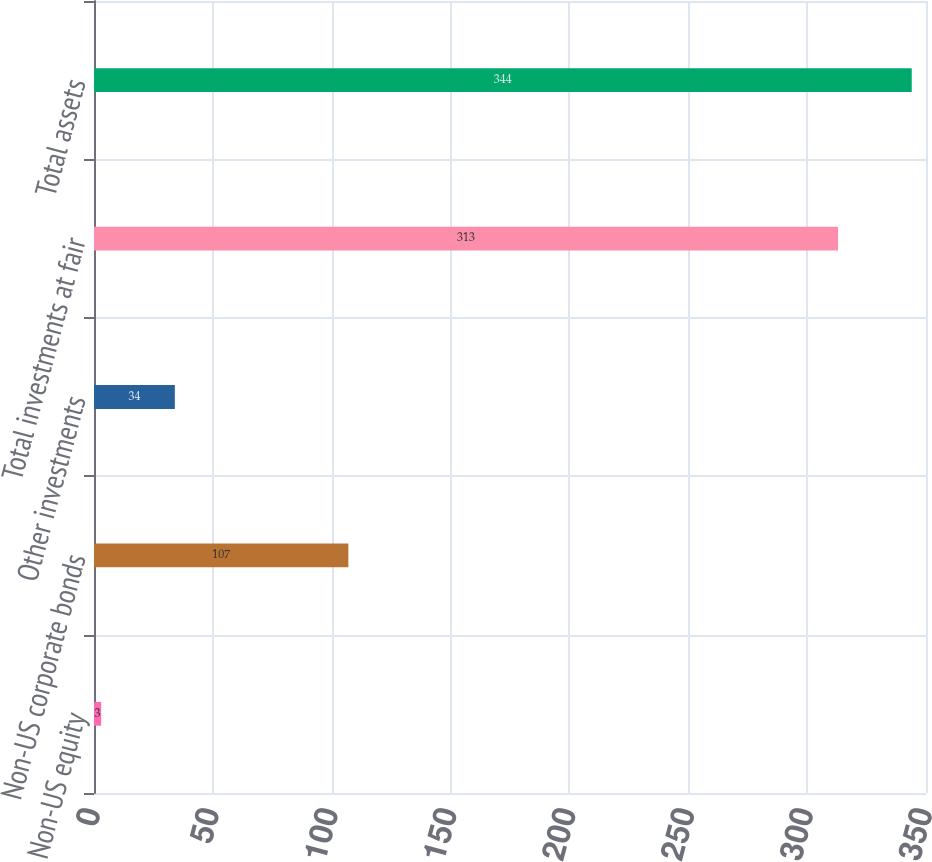Convert chart. <chart><loc_0><loc_0><loc_500><loc_500><bar_chart><fcel>Non-US equity<fcel>Non-US corporate bonds<fcel>Other investments<fcel>Total investments at fair<fcel>Total assets<nl><fcel>3<fcel>107<fcel>34<fcel>313<fcel>344<nl></chart> 